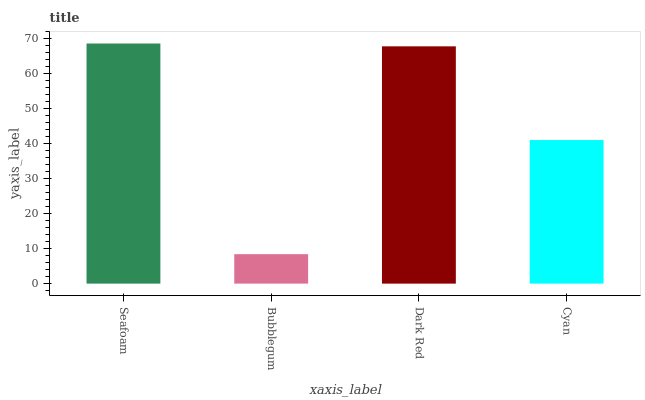Is Bubblegum the minimum?
Answer yes or no. Yes. Is Seafoam the maximum?
Answer yes or no. Yes. Is Dark Red the minimum?
Answer yes or no. No. Is Dark Red the maximum?
Answer yes or no. No. Is Dark Red greater than Bubblegum?
Answer yes or no. Yes. Is Bubblegum less than Dark Red?
Answer yes or no. Yes. Is Bubblegum greater than Dark Red?
Answer yes or no. No. Is Dark Red less than Bubblegum?
Answer yes or no. No. Is Dark Red the high median?
Answer yes or no. Yes. Is Cyan the low median?
Answer yes or no. Yes. Is Seafoam the high median?
Answer yes or no. No. Is Dark Red the low median?
Answer yes or no. No. 